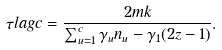Convert formula to latex. <formula><loc_0><loc_0><loc_500><loc_500>\tau l a g { c } = \frac { 2 m k } { \sum _ { u = 1 } ^ { c } \gamma _ { u } n _ { u } - \gamma _ { 1 } ( 2 z - 1 ) } .</formula> 